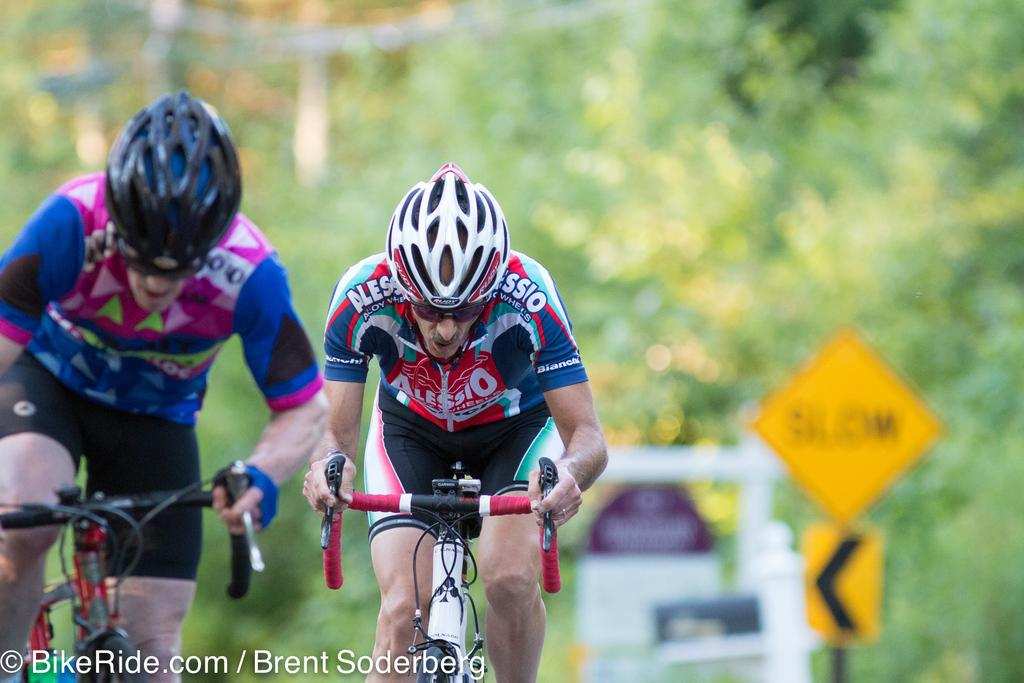How many people are riding the bicycle in the image? There are two people riding the bicycle in the image. What can be found at the bottom of the image? There is some text at the bottom of the image. What can be seen in the background of the image? There are banners and sign boards in the background of the image. How would you describe the background of the image? The background of the image is blurry. How many kittens are being taught in the image? There are no kittens or teaching activities present in the image. 